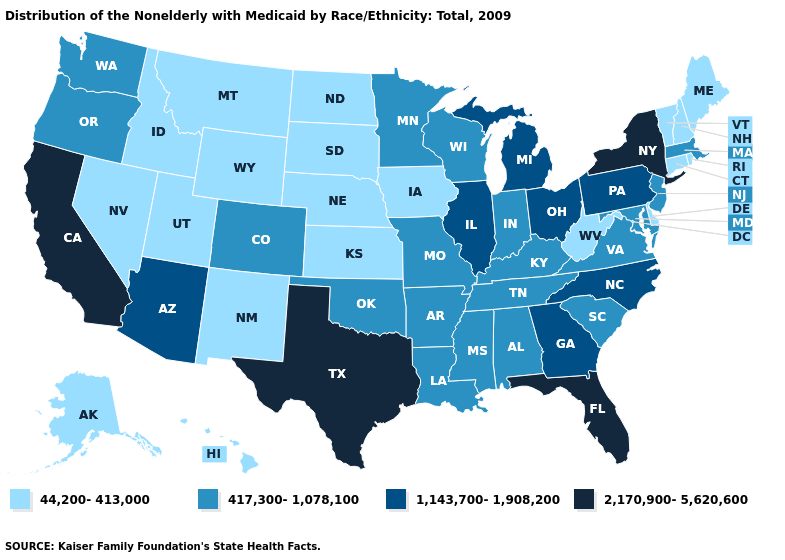What is the lowest value in states that border Rhode Island?
Short answer required. 44,200-413,000. What is the value of New Hampshire?
Be succinct. 44,200-413,000. What is the highest value in the USA?
Short answer required. 2,170,900-5,620,600. Which states hav the highest value in the South?
Give a very brief answer. Florida, Texas. Name the states that have a value in the range 44,200-413,000?
Be succinct. Alaska, Connecticut, Delaware, Hawaii, Idaho, Iowa, Kansas, Maine, Montana, Nebraska, Nevada, New Hampshire, New Mexico, North Dakota, Rhode Island, South Dakota, Utah, Vermont, West Virginia, Wyoming. Name the states that have a value in the range 44,200-413,000?
Write a very short answer. Alaska, Connecticut, Delaware, Hawaii, Idaho, Iowa, Kansas, Maine, Montana, Nebraska, Nevada, New Hampshire, New Mexico, North Dakota, Rhode Island, South Dakota, Utah, Vermont, West Virginia, Wyoming. Among the states that border Rhode Island , which have the lowest value?
Be succinct. Connecticut. What is the highest value in states that border Rhode Island?
Quick response, please. 417,300-1,078,100. Among the states that border Tennessee , does Virginia have the lowest value?
Keep it brief. Yes. Name the states that have a value in the range 1,143,700-1,908,200?
Short answer required. Arizona, Georgia, Illinois, Michigan, North Carolina, Ohio, Pennsylvania. Does Florida have the highest value in the USA?
Keep it brief. Yes. Name the states that have a value in the range 417,300-1,078,100?
Concise answer only. Alabama, Arkansas, Colorado, Indiana, Kentucky, Louisiana, Maryland, Massachusetts, Minnesota, Mississippi, Missouri, New Jersey, Oklahoma, Oregon, South Carolina, Tennessee, Virginia, Washington, Wisconsin. Does the first symbol in the legend represent the smallest category?
Write a very short answer. Yes. What is the value of Alabama?
Be succinct. 417,300-1,078,100. Which states have the highest value in the USA?
Give a very brief answer. California, Florida, New York, Texas. 